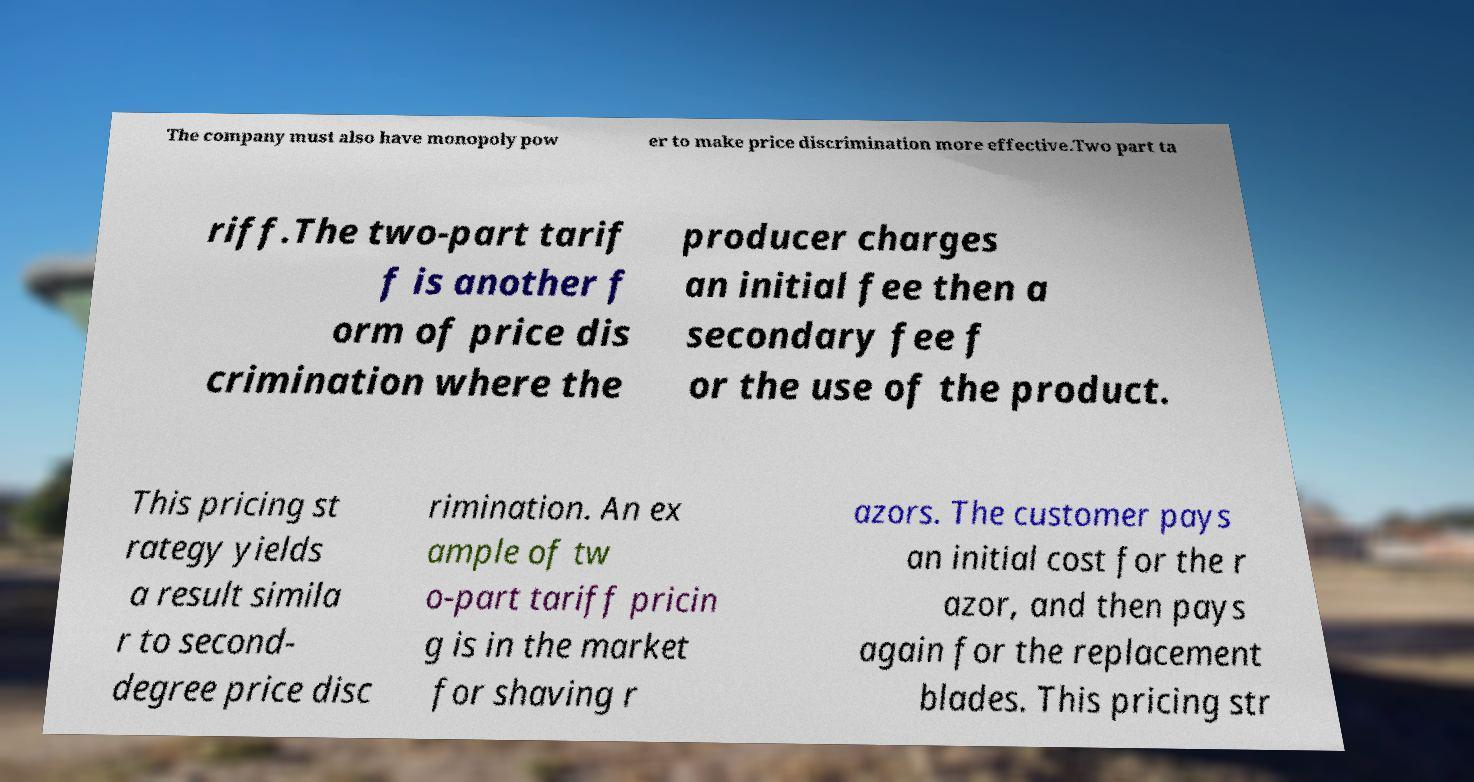For documentation purposes, I need the text within this image transcribed. Could you provide that? The company must also have monopoly pow er to make price discrimination more effective.Two part ta riff.The two-part tarif f is another f orm of price dis crimination where the producer charges an initial fee then a secondary fee f or the use of the product. This pricing st rategy yields a result simila r to second- degree price disc rimination. An ex ample of tw o-part tariff pricin g is in the market for shaving r azors. The customer pays an initial cost for the r azor, and then pays again for the replacement blades. This pricing str 